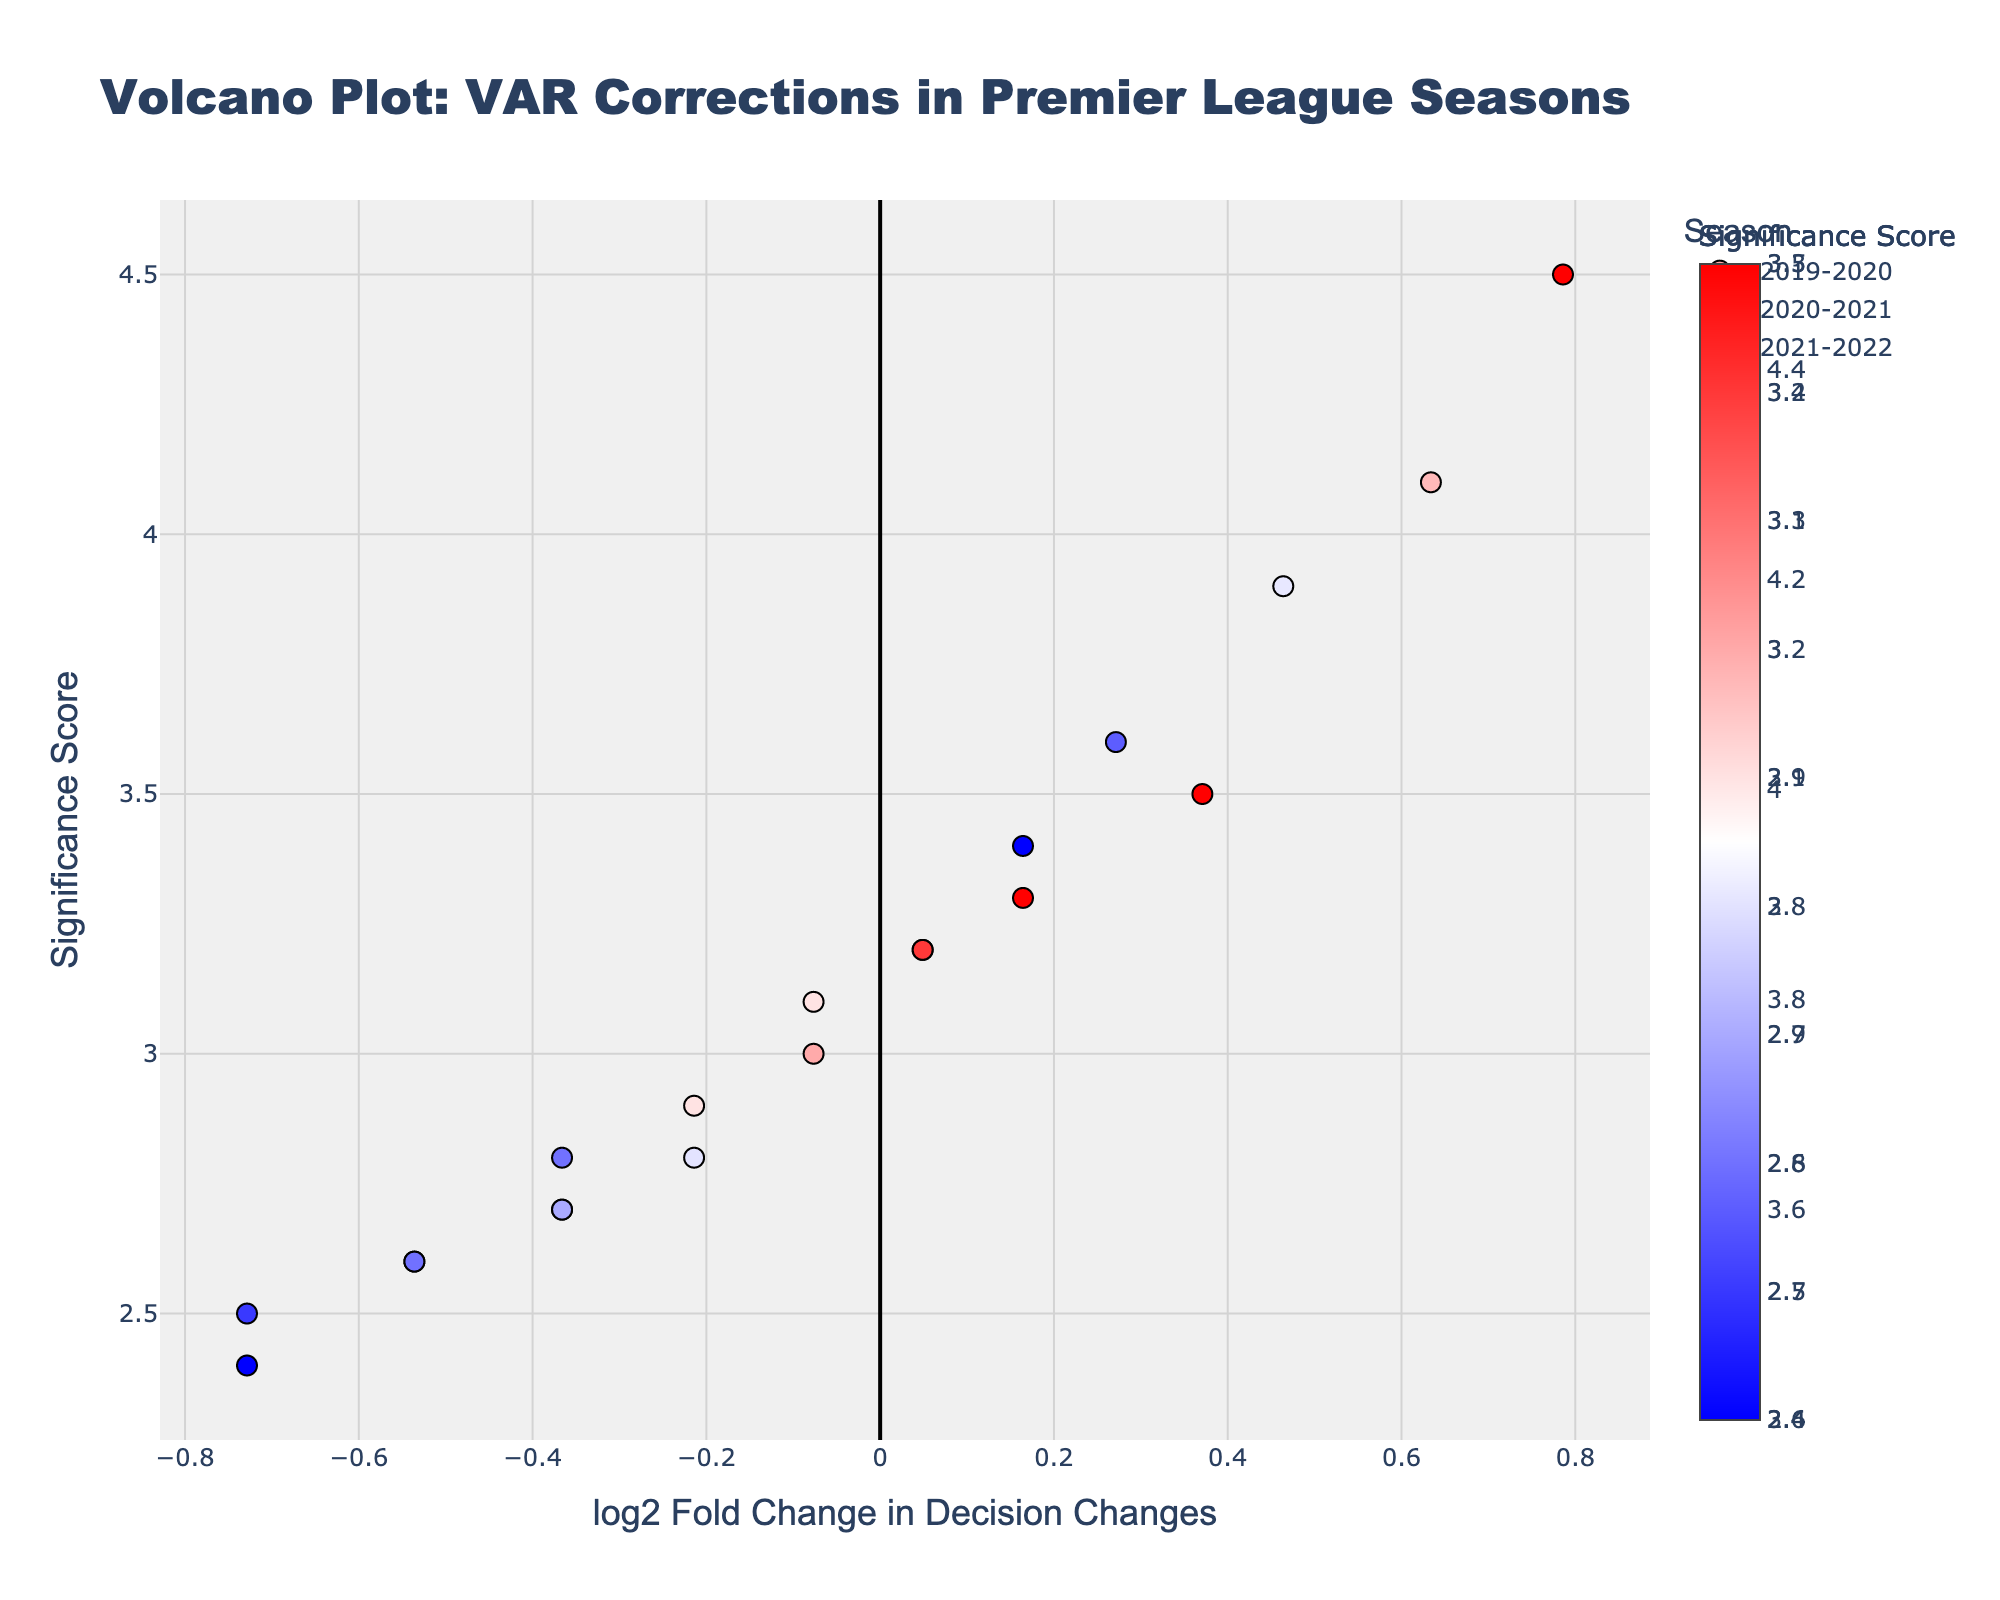What's the title of the plot? The title of the plot is generally displayed prominently and is designed to give a quick overview of the figure's main subject. In this plot, the title is at the top center.
Answer: Volcano Plot: VAR Corrections in Premier League Seasons How many referees are plotted in the 2021-2022 season? To determine the number of referees, you need to count the number of markers or points associated with the 2021-2022 season on the plot. Each point represents a different referee.
Answer: 8 Which season has the highest significance score and who is the referee? To answer this, look for the highest point on the y-axis representing the Significance Score and identify the season and referee associated with that point based on the hover information.
Answer: 2020-2021, Michael Oliver What does the color of a marker represent in this plot? In the plot, the color of a marker on a volcano plot usually represents an additional dimension of data. Here, it's specified in the legend as related to the Significance Score indicated by the color scale on the right.
Answer: Significance Score Which referee in the 2019-2020 season had the highest log2 Fold Change in decision changes? For this, look at the markers related to the 2019-2020 season and identify which one is the farthest on the x-axis towards the right, representing the highest log2 Fold Change.
Answer: Michael Oliver Identify the referee with the lowest decision changes in the 2020-2021 season. Scan the markers related to the 2020-2021 season and determine which one is positioned the farthest left on the x-axis for Decision Changes, as fold change is computed from decision changes.
Answer: Andre Marriner What is the general trend for 'Significance Score' across the seasons for Mike Dean? To answer this, trace the markers corresponding to Mike Dean across different seasons and observe the trend by comparing their y-axis positions (Significance Scores).
Answer: Increasing in 2020-2021, then decreasing in 2021-2022 Comparing 2019-2020 and 2021-2022, which season had a higher average 'log2 Fold Change' for referees? Calculate the average log2 Fold Change for referees in each season by summing their log2 Fold Change values and dividing by the number of referees, then compare the averages.
Answer: 2021-2022 How do 'Decision Changes' generally correlate with 'Significance Score' in this plot? Observe the scatter pattern; if higher points on the y-axis generally align with points further along the x-axis, a positive correlation is suggested. The nature of this correlation reveals insights on how decision changes affect significance scores.
Answer: Positive correlation Which season, in general, saw more decision changes corrected by VAR? To determine this, look at the concentration of markers along the x-axis representing Decision Changes (fold change), visually assess the bulk of markers farthest along this axis for each season.
Answer: 2020-2021 